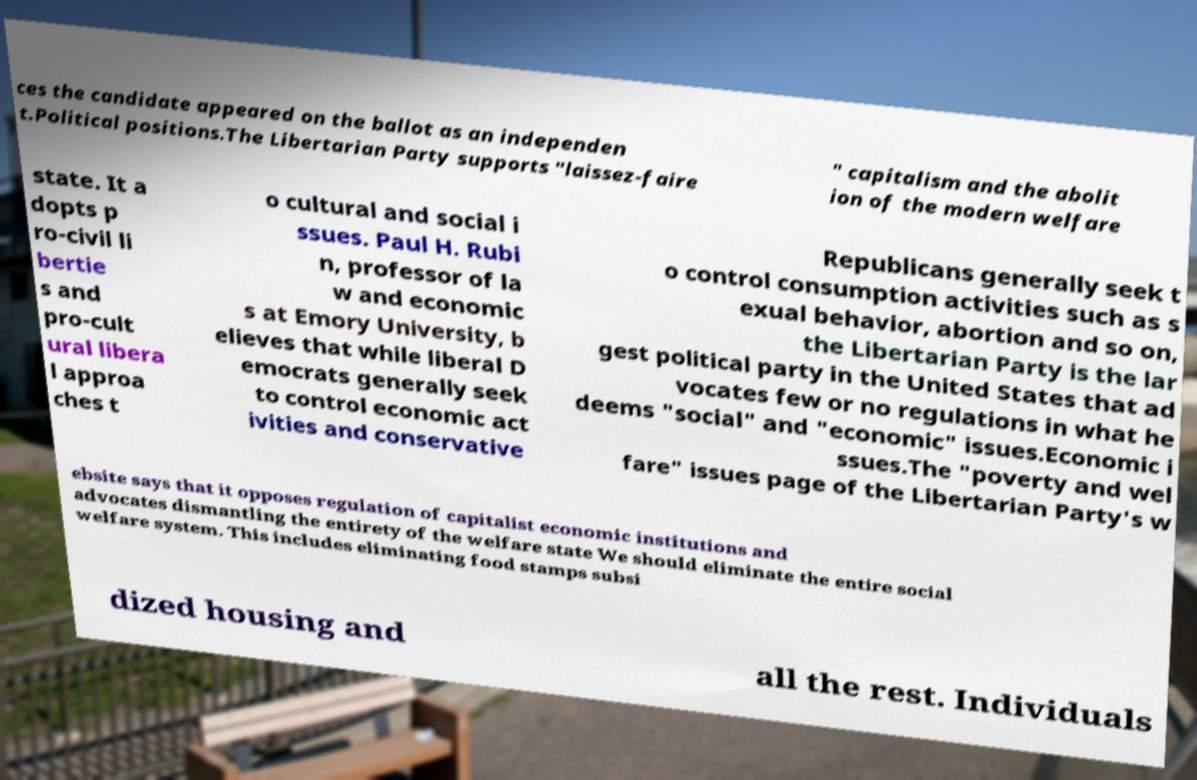Can you accurately transcribe the text from the provided image for me? ces the candidate appeared on the ballot as an independen t.Political positions.The Libertarian Party supports "laissez-faire " capitalism and the abolit ion of the modern welfare state. It a dopts p ro-civil li bertie s and pro-cult ural libera l approa ches t o cultural and social i ssues. Paul H. Rubi n, professor of la w and economic s at Emory University, b elieves that while liberal D emocrats generally seek to control economic act ivities and conservative Republicans generally seek t o control consumption activities such as s exual behavior, abortion and so on, the Libertarian Party is the lar gest political party in the United States that ad vocates few or no regulations in what he deems "social" and "economic" issues.Economic i ssues.The "poverty and wel fare" issues page of the Libertarian Party's w ebsite says that it opposes regulation of capitalist economic institutions and advocates dismantling the entirety of the welfare state We should eliminate the entire social welfare system. This includes eliminating food stamps subsi dized housing and all the rest. Individuals 